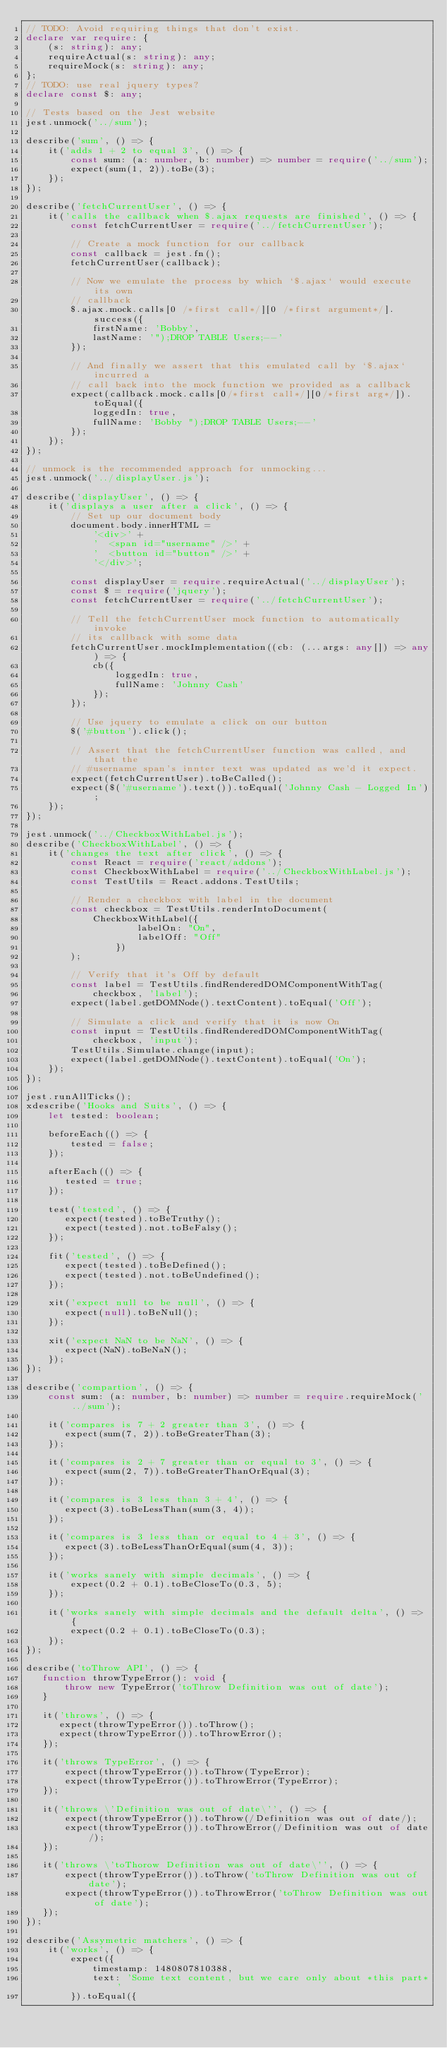<code> <loc_0><loc_0><loc_500><loc_500><_TypeScript_>// TODO: Avoid requiring things that don't exist.
declare var require: {
    (s: string): any;
    requireActual(s: string): any;
    requireMock(s: string): any;
};
// TODO: use real jquery types?
declare const $: any;

// Tests based on the Jest website
jest.unmock('../sum');

describe('sum', () => {
    it('adds 1 + 2 to equal 3', () => {
        const sum: (a: number, b: number) => number = require('../sum');
        expect(sum(1, 2)).toBe(3);
    });
});

describe('fetchCurrentUser', () => {
    it('calls the callback when $.ajax requests are finished', () => {
        const fetchCurrentUser = require('../fetchCurrentUser');

        // Create a mock function for our callback
        const callback = jest.fn();
        fetchCurrentUser(callback);

        // Now we emulate the process by which `$.ajax` would execute its own
        // callback
        $.ajax.mock.calls[0 /*first call*/][0 /*first argument*/].success({
            firstName: 'Bobby',
            lastName: '");DROP TABLE Users;--'
        });

        // And finally we assert that this emulated call by `$.ajax` incurred a
        // call back into the mock function we provided as a callback
        expect(callback.mock.calls[0/*first call*/][0/*first arg*/]).toEqual({
            loggedIn: true,
            fullName: 'Bobby ");DROP TABLE Users;--'
        });
    });
});

// unmock is the recommended approach for unmocking...
jest.unmock('../displayUser.js');

describe('displayUser', () => {
    it('displays a user after a click', () => {
        // Set up our document body
        document.body.innerHTML =
            '<div>' +
            '  <span id="username" />' +
            '  <button id="button" />' +
            '</div>';

        const displayUser = require.requireActual('../displayUser');
        const $ = require('jquery');
        const fetchCurrentUser = require('../fetchCurrentUser');

        // Tell the fetchCurrentUser mock function to automatically invoke
        // its callback with some data
        fetchCurrentUser.mockImplementation((cb: (...args: any[]) => any) => {
            cb({
                loggedIn: true,
                fullName: 'Johnny Cash'
            });
        });

        // Use jquery to emulate a click on our button
        $('#button').click();

        // Assert that the fetchCurrentUser function was called, and that the
        // #username span's innter text was updated as we'd it expect.
        expect(fetchCurrentUser).toBeCalled();
        expect($('#username').text()).toEqual('Johnny Cash - Logged In');
    });
});

jest.unmock('../CheckboxWithLabel.js');
describe('CheckboxWithLabel', () => {
    it('changes the text after click', () => {
        const React = require('react/addons');
        const CheckboxWithLabel = require('../CheckboxWithLabel.js');
        const TestUtils = React.addons.TestUtils;

        // Render a checkbox with label in the document
        const checkbox = TestUtils.renderIntoDocument(
            CheckboxWithLabel({
                    labelOn: "On",
                    labelOff: "Off"
                })
        );

        // Verify that it's Off by default
        const label = TestUtils.findRenderedDOMComponentWithTag(
            checkbox, 'label');
        expect(label.getDOMNode().textContent).toEqual('Off');

        // Simulate a click and verify that it is now On
        const input = TestUtils.findRenderedDOMComponentWithTag(
            checkbox, 'input');
        TestUtils.Simulate.change(input);
        expect(label.getDOMNode().textContent).toEqual('On');
    });
});

jest.runAllTicks();
xdescribe('Hooks and Suits', () => {
    let tested: boolean;

    beforeEach(() => {
        tested = false;
    });

    afterEach(() => {
       tested = true;
    });

    test('tested', () => {
       expect(tested).toBeTruthy();
       expect(tested).not.toBeFalsy();
    });

    fit('tested', () => {
       expect(tested).toBeDefined();
       expect(tested).not.toBeUndefined();
    });

    xit('expect null to be null', () => {
       expect(null).toBeNull();
    });

    xit('expect NaN to be NaN', () => {
       expect(NaN).toBeNaN();
    });
});

describe('compartion', () => {
    const sum: (a: number, b: number) => number = require.requireMock('../sum');

    it('compares is 7 + 2 greater than 3', () => {
       expect(sum(7, 2)).toBeGreaterThan(3);
    });

    it('compares is 2 + 7 greater than or equal to 3', () => {
       expect(sum(2, 7)).toBeGreaterThanOrEqual(3);
    });

    it('compares is 3 less than 3 + 4', () => {
       expect(3).toBeLessThan(sum(3, 4));
    });

    it('compares is 3 less than or equal to 4 + 3', () => {
       expect(3).toBeLessThanOrEqual(sum(4, 3));
    });

    it('works sanely with simple decimals', () => {
        expect(0.2 + 0.1).toBeCloseTo(0.3, 5);
    });

    it('works sanely with simple decimals and the default delta', () => {
        expect(0.2 + 0.1).toBeCloseTo(0.3);
    });
});

describe('toThrow API', () => {
   function throwTypeError(): void {
       throw new TypeError('toThrow Definition was out of date');
   }

   it('throws', () => {
      expect(throwTypeError()).toThrow();
      expect(throwTypeError()).toThrowError();
   });

   it('throws TypeError', () => {
       expect(throwTypeError()).toThrow(TypeError);
       expect(throwTypeError()).toThrowError(TypeError);
   });

   it('throws \'Definition was out of date\'', () => {
       expect(throwTypeError()).toThrow(/Definition was out of date/);
       expect(throwTypeError()).toThrowError(/Definition was out of date/);
   });

   it('throws \'toThorow Definition was out of date\'', () => {
       expect(throwTypeError()).toThrow('toThrow Definition was out of date');
       expect(throwTypeError()).toThrowError('toThrow Definition was out of date');
   });
});

describe('Assymetric matchers', () => {
    it('works', () => {
        expect({
            timestamp: 1480807810388,
            text: 'Some text content, but we care only about *this part*'
        }).toEqual({</code> 